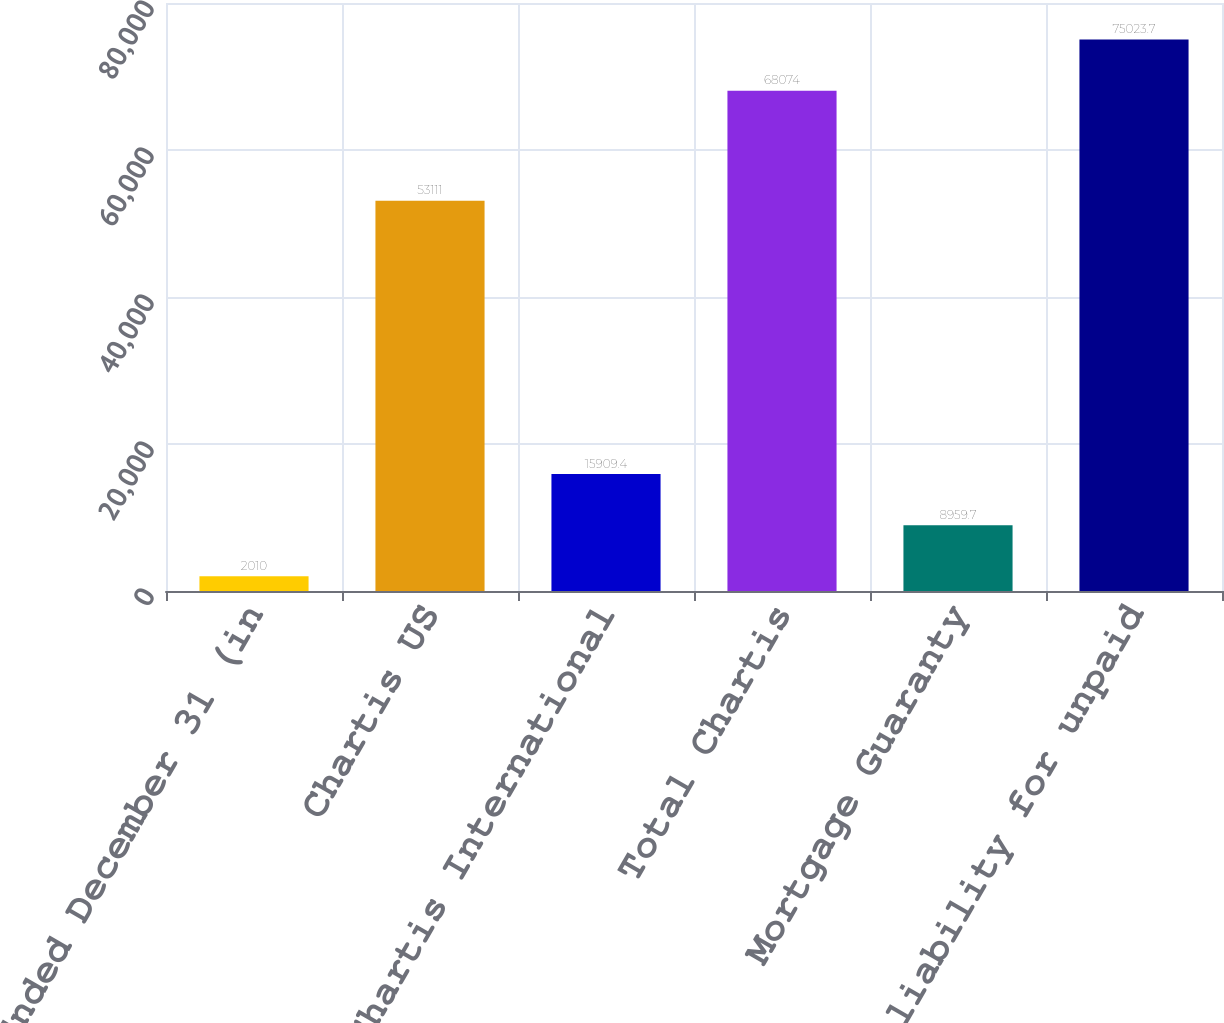Convert chart to OTSL. <chart><loc_0><loc_0><loc_500><loc_500><bar_chart><fcel>Years Ended December 31 (in<fcel>Chartis US<fcel>Chartis International<fcel>Total Chartis<fcel>Mortgage Guaranty<fcel>Net liability for unpaid<nl><fcel>2010<fcel>53111<fcel>15909.4<fcel>68074<fcel>8959.7<fcel>75023.7<nl></chart> 